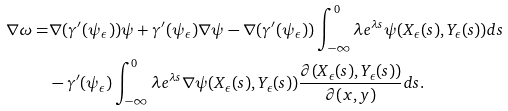<formula> <loc_0><loc_0><loc_500><loc_500>\nabla \omega = & \nabla ( \gamma ^ { \prime } ( \psi _ { \epsilon } ) ) \psi + \gamma ^ { \prime } ( \psi _ { \epsilon } ) \nabla \psi - \nabla ( \gamma ^ { \prime } ( \psi _ { \epsilon } ) ) \int _ { - \infty } ^ { 0 } \lambda e ^ { \lambda s } \psi ( X _ { \epsilon } ( s ) , Y _ { \epsilon } ( s ) ) d s \\ & - \gamma ^ { \prime } ( \psi _ { \epsilon } ) \int _ { - \infty } ^ { 0 } \lambda e ^ { \lambda s } \nabla \psi ( X _ { \epsilon } ( s ) , Y _ { \epsilon } ( s ) ) \frac { \partial ( X _ { \epsilon } ( s ) , Y _ { \epsilon } ( s ) ) } { \partial ( x , y ) } d s .</formula> 